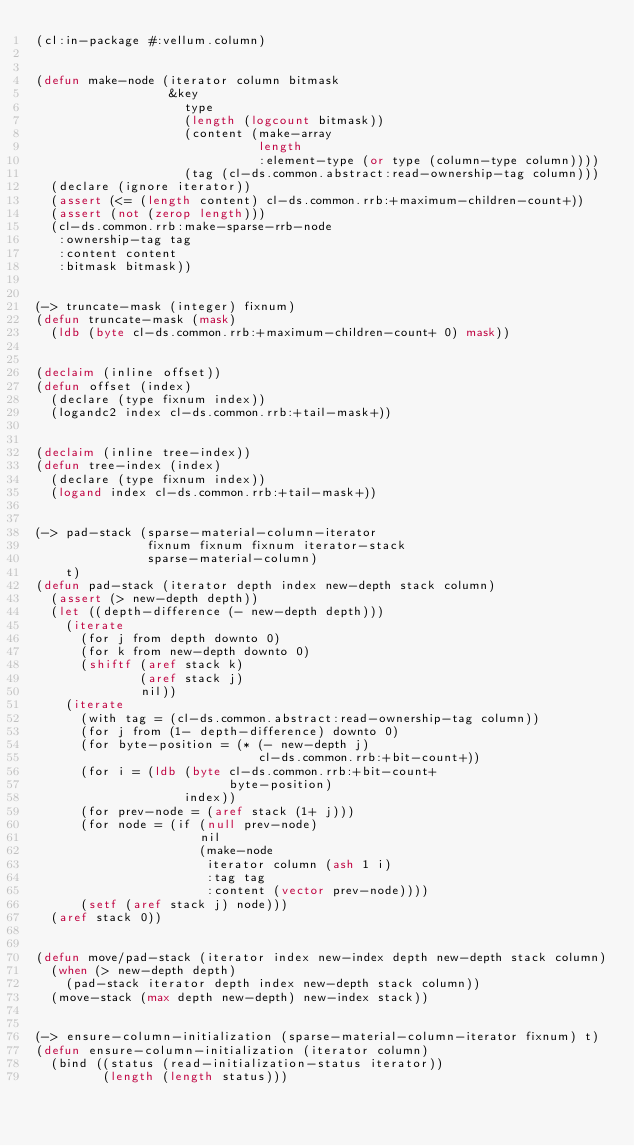Convert code to text. <code><loc_0><loc_0><loc_500><loc_500><_Lisp_>(cl:in-package #:vellum.column)


(defun make-node (iterator column bitmask
                  &key
                    type
                    (length (logcount bitmask))
                    (content (make-array
                              length
                              :element-type (or type (column-type column))))
                    (tag (cl-ds.common.abstract:read-ownership-tag column)))
  (declare (ignore iterator))
  (assert (<= (length content) cl-ds.common.rrb:+maximum-children-count+))
  (assert (not (zerop length)))
  (cl-ds.common.rrb:make-sparse-rrb-node
   :ownership-tag tag
   :content content
   :bitmask bitmask))


(-> truncate-mask (integer) fixnum)
(defun truncate-mask (mask)
  (ldb (byte cl-ds.common.rrb:+maximum-children-count+ 0) mask))


(declaim (inline offset))
(defun offset (index)
  (declare (type fixnum index))
  (logandc2 index cl-ds.common.rrb:+tail-mask+))


(declaim (inline tree-index))
(defun tree-index (index)
  (declare (type fixnum index))
  (logand index cl-ds.common.rrb:+tail-mask+))


(-> pad-stack (sparse-material-column-iterator
               fixnum fixnum fixnum iterator-stack
               sparse-material-column)
    t)
(defun pad-stack (iterator depth index new-depth stack column)
  (assert (> new-depth depth))
  (let ((depth-difference (- new-depth depth)))
    (iterate
      (for j from depth downto 0)
      (for k from new-depth downto 0)
      (shiftf (aref stack k)
              (aref stack j)
              nil))
    (iterate
      (with tag = (cl-ds.common.abstract:read-ownership-tag column))
      (for j from (1- depth-difference) downto 0)
      (for byte-position = (* (- new-depth j)
                              cl-ds.common.rrb:+bit-count+))
      (for i = (ldb (byte cl-ds.common.rrb:+bit-count+
                          byte-position)
                    index))
      (for prev-node = (aref stack (1+ j)))
      (for node = (if (null prev-node)
                      nil
                      (make-node
                       iterator column (ash 1 i)
                       :tag tag
                       :content (vector prev-node))))
      (setf (aref stack j) node)))
  (aref stack 0))


(defun move/pad-stack (iterator index new-index depth new-depth stack column)
  (when (> new-depth depth)
    (pad-stack iterator depth index new-depth stack column))
  (move-stack (max depth new-depth) new-index stack))


(-> ensure-column-initialization (sparse-material-column-iterator fixnum) t)
(defun ensure-column-initialization (iterator column)
  (bind ((status (read-initialization-status iterator))
         (length (length status)))</code> 